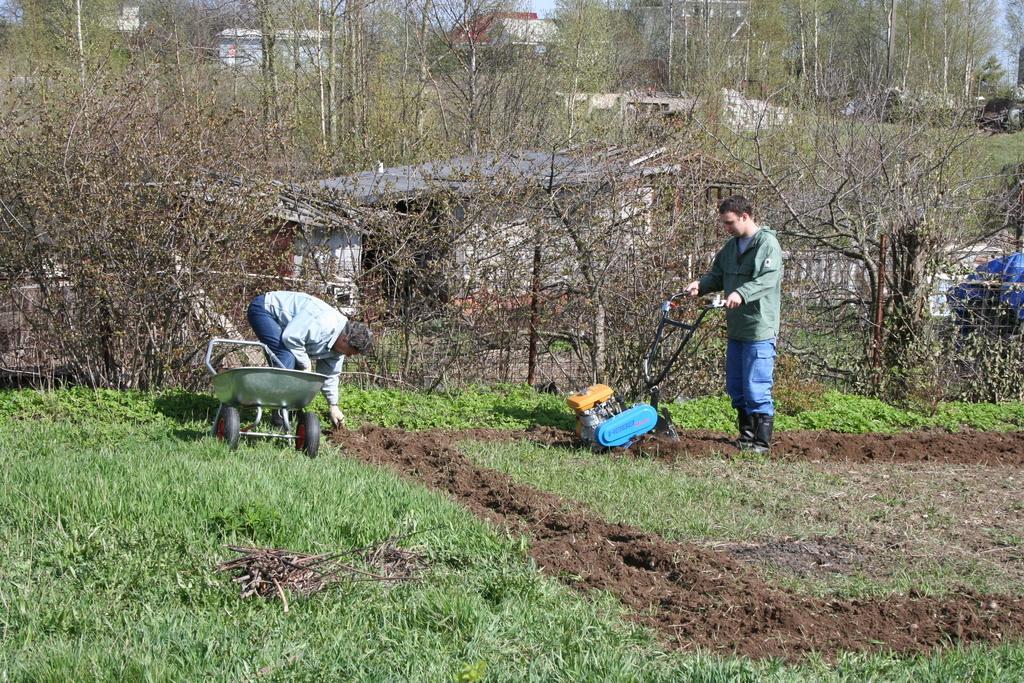In one or two sentences, can you explain what this image depicts? In the image we can see two men wearing clothes. This is a soil, grass, trees and buildings. We can even see the pale blue sky and a machine. 